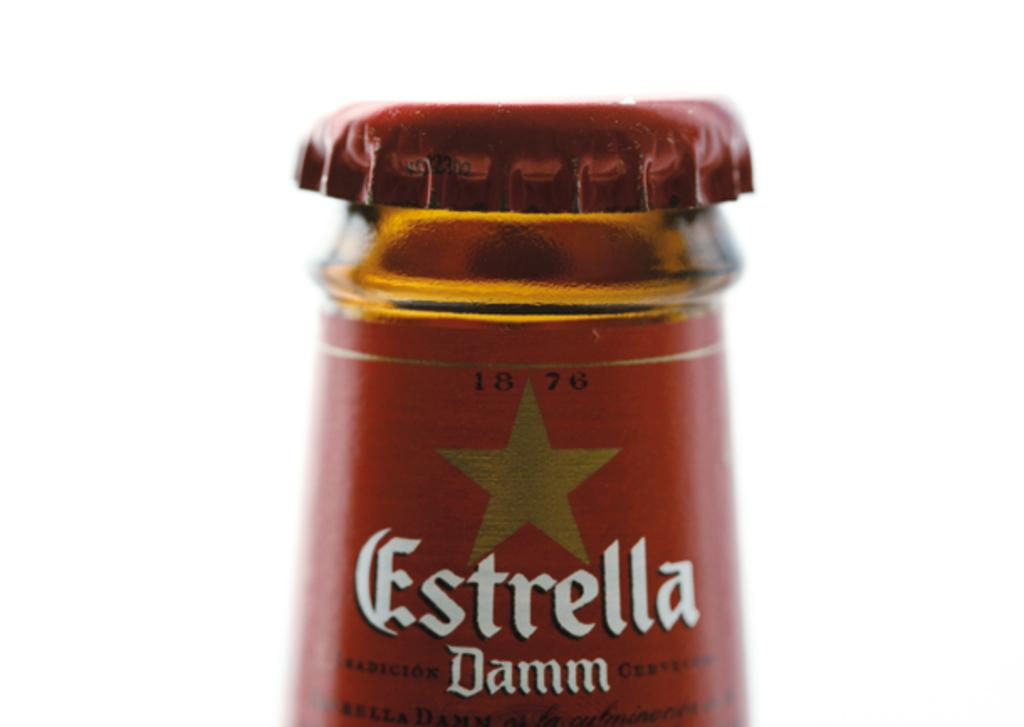<image>
Render a clear and concise summary of the photo. The top of a bottle of a drink called Estrella Damm 